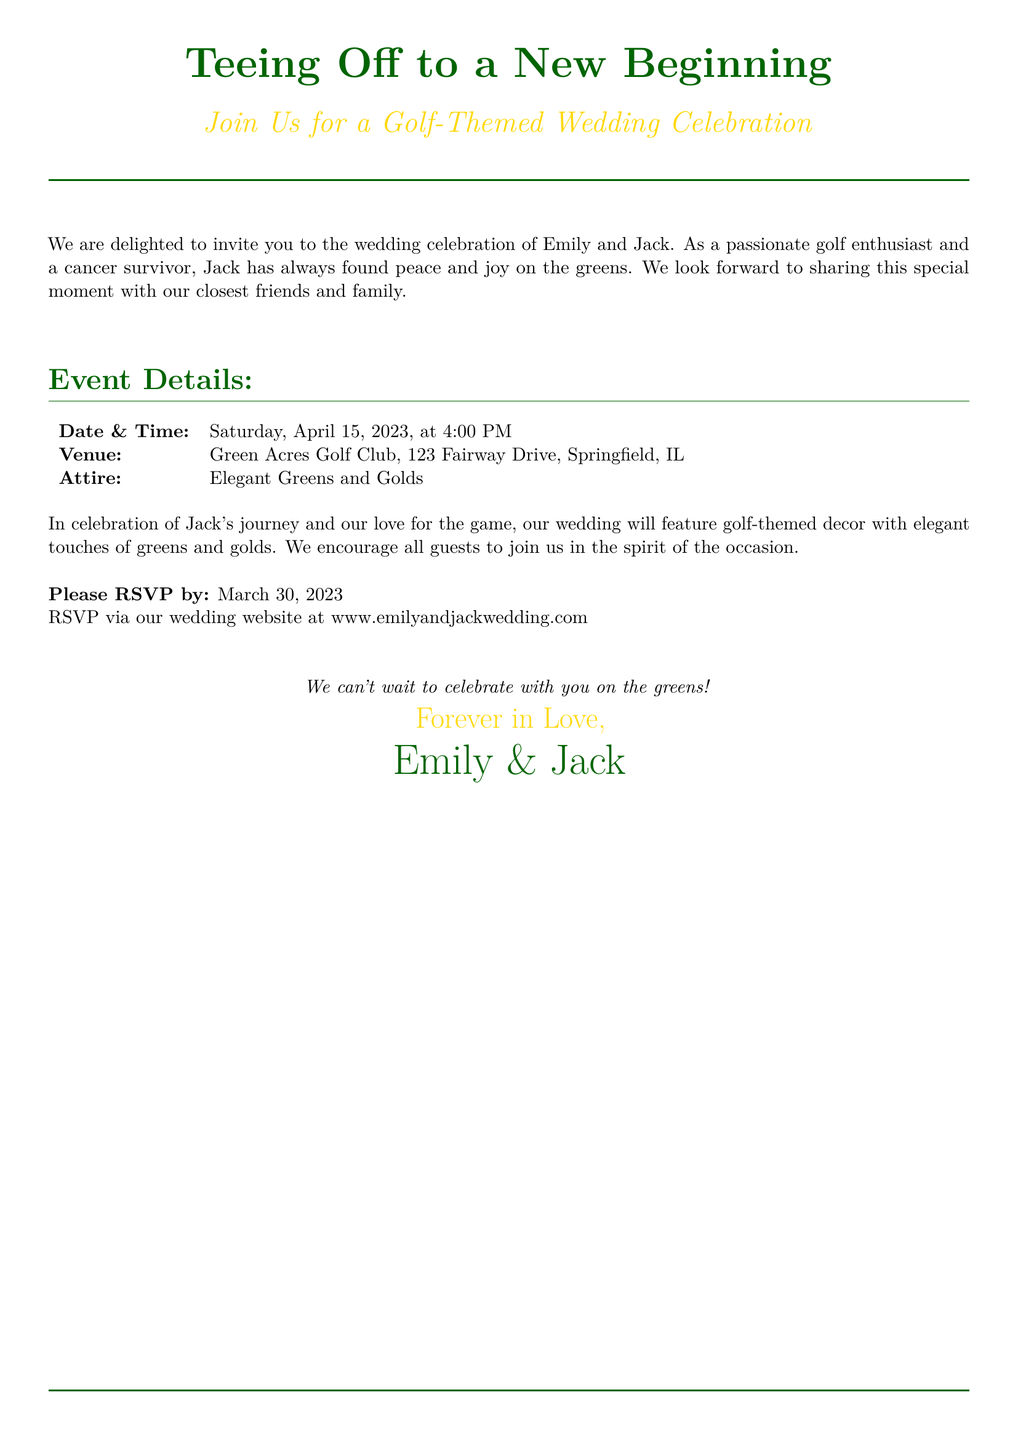What is the title of the invitation? The title of the invitation is prominently displayed at the top, "Teeing Off to a New Beginning."
Answer: Tee Off to a New Beginning Who are the couple getting married? The names of the couple are mentioned in the invitation, explicitly stating who is getting married.
Answer: Emily and Jack What is the date of the wedding? The specific date of the wedding is provided in the invitation details.
Answer: Saturday, April 15, 2023 What color scheme is encouraged for the attire? The invitation describes the attire color scheme that guests are encouraged to wear.
Answer: Elegant Greens and Golds What venue will host the wedding celebration? The venue details are given in the invitation, indicating the location of the wedding.
Answer: Green Acres Golf Club What is the RSVP deadline? The invitation specifies a deadline for guests to respond to the invitation.
Answer: March 30, 2023 Why is golf significant to Jack? The invitation mentions Jack's personal connection to golf, highlighting its meaning to him.
Answer: Peace and joy on the greens What is the theme of the wedding? The invitation clearly states the overarching theme of the wedding celebration.
Answer: Golf-themed How should guests RSVP? The invitation provides instructions on how guests can confirm their attendance.
Answer: Via our wedding website What sentiment is expressed at the end of the invitation? The closing lines of the invitation convey a particular feeling the couple wishes to share.
Answer: We can't wait to celebrate with you on the greens! 